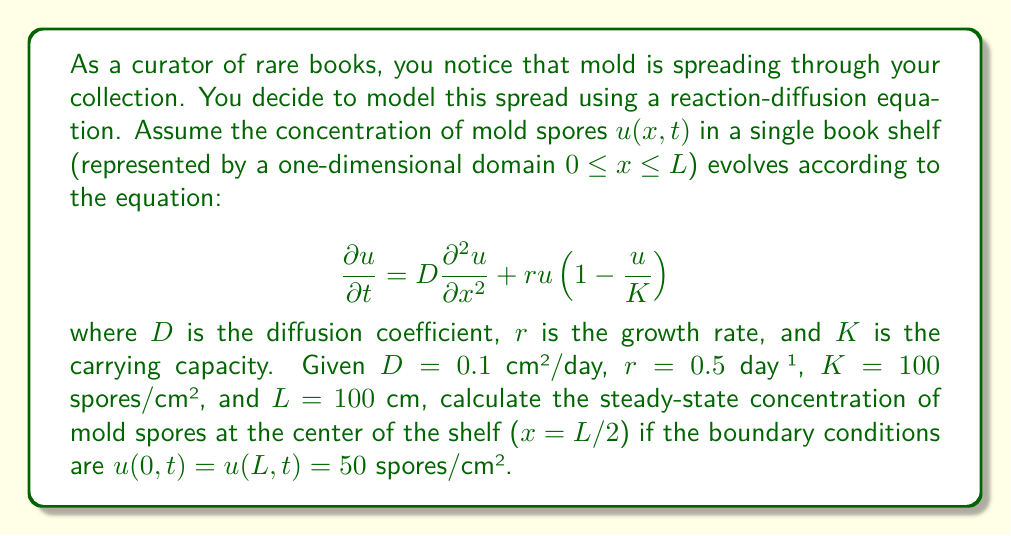Could you help me with this problem? To solve this problem, we need to find the steady-state solution of the reaction-diffusion equation. At steady state, the concentration doesn't change with time, so $\frac{\partial u}{\partial t} = 0$. This gives us:

$$0 = D\frac{d^2 u}{dx^2} + ru(1-\frac{u}{K})$$

We're looking for a solution that satisfies the boundary conditions $u(0) = u(L) = 50$.

Given the symmetry of the problem and the boundary conditions, we can deduce that the steady-state solution will be symmetric around $x = L/2$, and the maximum concentration will occur at this point.

At $x = L/2$, due to symmetry, we know that $\frac{du}{dx} = 0$. Let's call the concentration at this point $u_m$. Then:

$$0 = ru_m(1-\frac{u_m}{K})$$

This equation has two solutions: $u_m = 0$ or $u_m = K = 100$.

Given that the boundary conditions are non-zero (50 spores/cm²), the solution $u_m = 0$ is not applicable. Therefore, the steady-state concentration at the center of the shelf will be equal to the carrying capacity:

$u(L/2) = K = 100$ spores/cm²

This result is independent of the diffusion coefficient $D$ and the growth rate $r$, as long as both are positive. The steady-state solution in this case is a flat profile at the carrying capacity $K$.
Answer: The steady-state concentration of mold spores at the center of the shelf ($x = L/2$) is 100 spores/cm². 